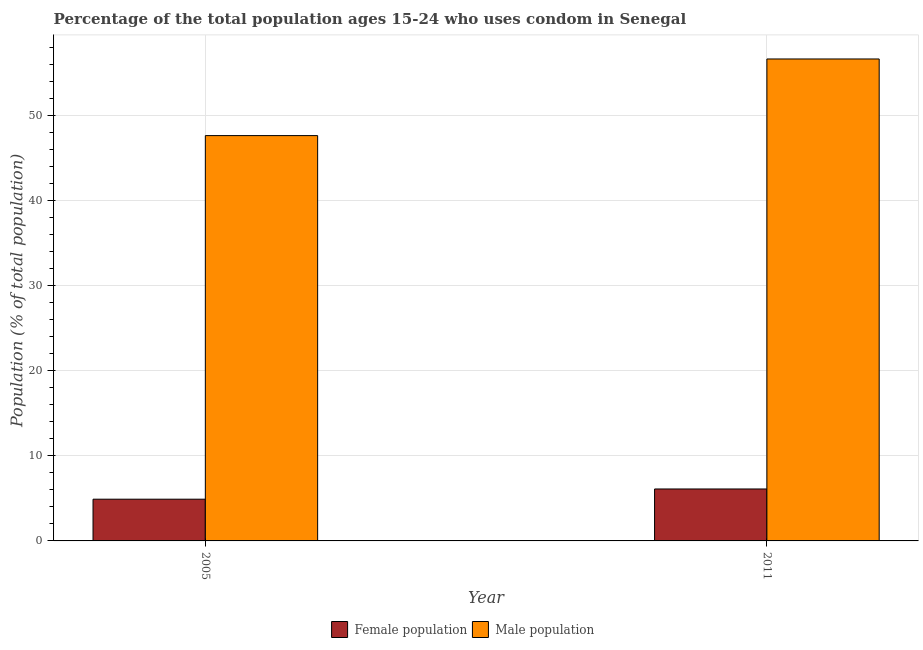Are the number of bars on each tick of the X-axis equal?
Give a very brief answer. Yes. How many bars are there on the 1st tick from the left?
Provide a succinct answer. 2. What is the label of the 1st group of bars from the left?
Your response must be concise. 2005. In how many cases, is the number of bars for a given year not equal to the number of legend labels?
Your answer should be compact. 0. What is the male population in 2011?
Offer a very short reply. 56.6. Across all years, what is the maximum male population?
Offer a very short reply. 56.6. Across all years, what is the minimum male population?
Your answer should be very brief. 47.6. In which year was the female population maximum?
Your answer should be compact. 2011. What is the average male population per year?
Ensure brevity in your answer.  52.1. In the year 2011, what is the difference between the male population and female population?
Provide a succinct answer. 0. What is the ratio of the female population in 2005 to that in 2011?
Your answer should be compact. 0.8. In how many years, is the female population greater than the average female population taken over all years?
Provide a succinct answer. 1. What does the 1st bar from the left in 2005 represents?
Provide a short and direct response. Female population. What does the 1st bar from the right in 2005 represents?
Provide a short and direct response. Male population. Are all the bars in the graph horizontal?
Provide a short and direct response. No. Are the values on the major ticks of Y-axis written in scientific E-notation?
Keep it short and to the point. No. Does the graph contain any zero values?
Offer a terse response. No. Where does the legend appear in the graph?
Provide a short and direct response. Bottom center. How are the legend labels stacked?
Make the answer very short. Horizontal. What is the title of the graph?
Provide a succinct answer. Percentage of the total population ages 15-24 who uses condom in Senegal. Does "Number of arrivals" appear as one of the legend labels in the graph?
Ensure brevity in your answer.  No. What is the label or title of the X-axis?
Offer a terse response. Year. What is the label or title of the Y-axis?
Your answer should be very brief. Population (% of total population) . What is the Population (% of total population)  in Female population in 2005?
Offer a very short reply. 4.9. What is the Population (% of total population)  in Male population in 2005?
Provide a succinct answer. 47.6. What is the Population (% of total population)  in Female population in 2011?
Your answer should be very brief. 6.1. What is the Population (% of total population)  in Male population in 2011?
Offer a terse response. 56.6. Across all years, what is the maximum Population (% of total population)  of Female population?
Offer a very short reply. 6.1. Across all years, what is the maximum Population (% of total population)  of Male population?
Ensure brevity in your answer.  56.6. Across all years, what is the minimum Population (% of total population)  in Male population?
Make the answer very short. 47.6. What is the total Population (% of total population)  in Male population in the graph?
Give a very brief answer. 104.2. What is the difference between the Population (% of total population)  in Male population in 2005 and that in 2011?
Your answer should be very brief. -9. What is the difference between the Population (% of total population)  in Female population in 2005 and the Population (% of total population)  in Male population in 2011?
Ensure brevity in your answer.  -51.7. What is the average Population (% of total population)  in Male population per year?
Ensure brevity in your answer.  52.1. In the year 2005, what is the difference between the Population (% of total population)  in Female population and Population (% of total population)  in Male population?
Your answer should be very brief. -42.7. In the year 2011, what is the difference between the Population (% of total population)  in Female population and Population (% of total population)  in Male population?
Provide a short and direct response. -50.5. What is the ratio of the Population (% of total population)  in Female population in 2005 to that in 2011?
Make the answer very short. 0.8. What is the ratio of the Population (% of total population)  in Male population in 2005 to that in 2011?
Ensure brevity in your answer.  0.84. What is the difference between the highest and the second highest Population (% of total population)  of Female population?
Make the answer very short. 1.2. What is the difference between the highest and the lowest Population (% of total population)  in Female population?
Your answer should be very brief. 1.2. 